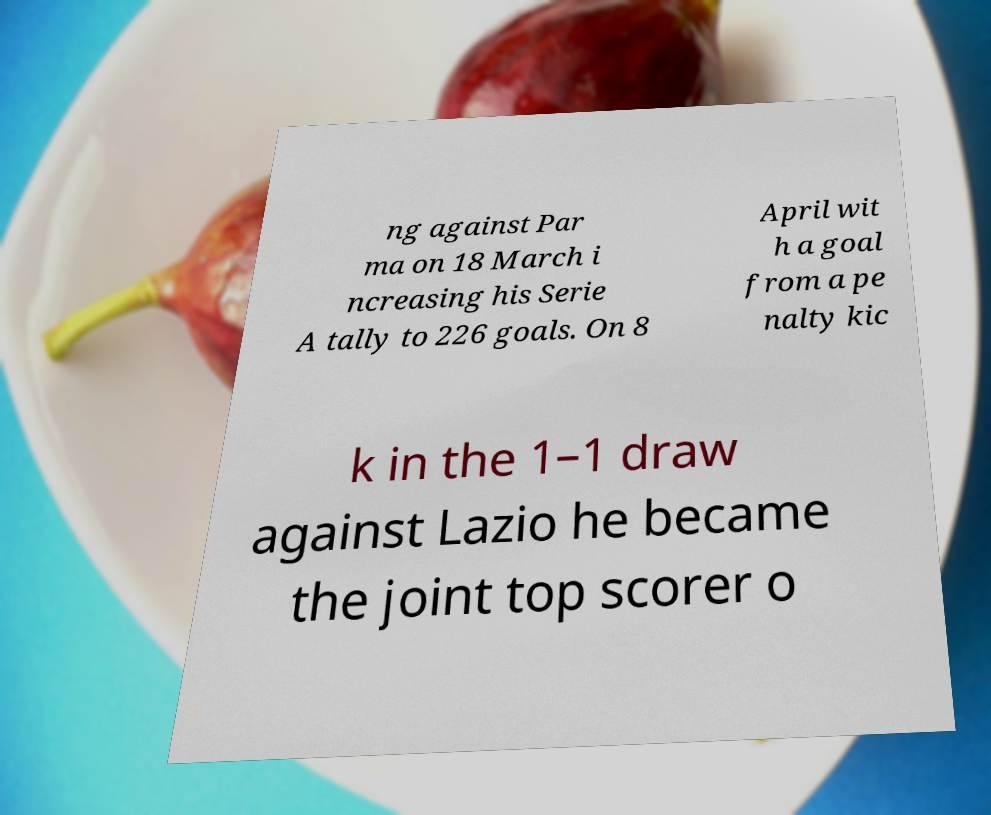Can you read and provide the text displayed in the image?This photo seems to have some interesting text. Can you extract and type it out for me? ng against Par ma on 18 March i ncreasing his Serie A tally to 226 goals. On 8 April wit h a goal from a pe nalty kic k in the 1–1 draw against Lazio he became the joint top scorer o 